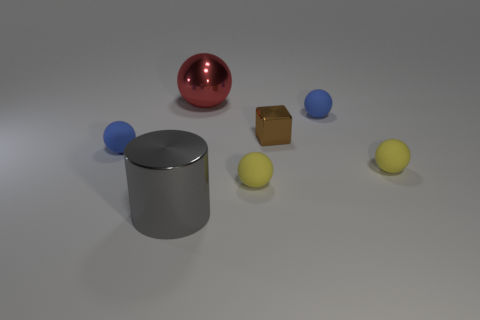Subtract all large metal balls. How many balls are left? 4 Subtract all brown balls. Subtract all cyan cubes. How many balls are left? 5 Add 2 big shiny spheres. How many objects exist? 9 Subtract all balls. How many objects are left? 2 Add 2 tiny gray rubber cylinders. How many tiny gray rubber cylinders exist? 2 Subtract 0 red blocks. How many objects are left? 7 Subtract all brown things. Subtract all large cylinders. How many objects are left? 5 Add 5 large spheres. How many large spheres are left? 6 